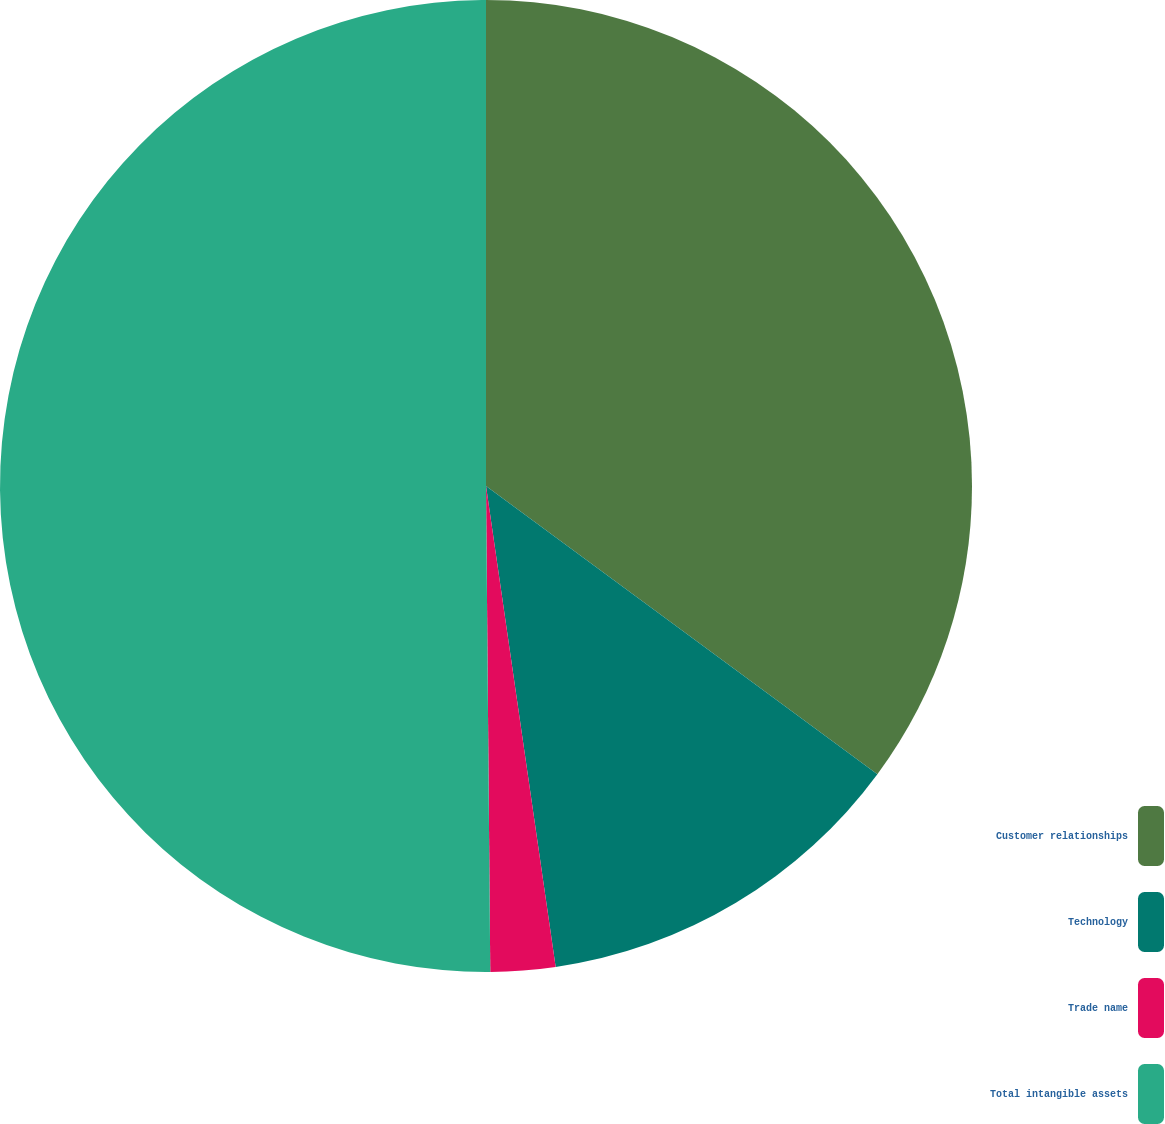Convert chart. <chart><loc_0><loc_0><loc_500><loc_500><pie_chart><fcel>Customer relationships<fcel>Technology<fcel>Trade name<fcel>Total intangible assets<nl><fcel>35.1%<fcel>12.61%<fcel>2.15%<fcel>50.14%<nl></chart> 